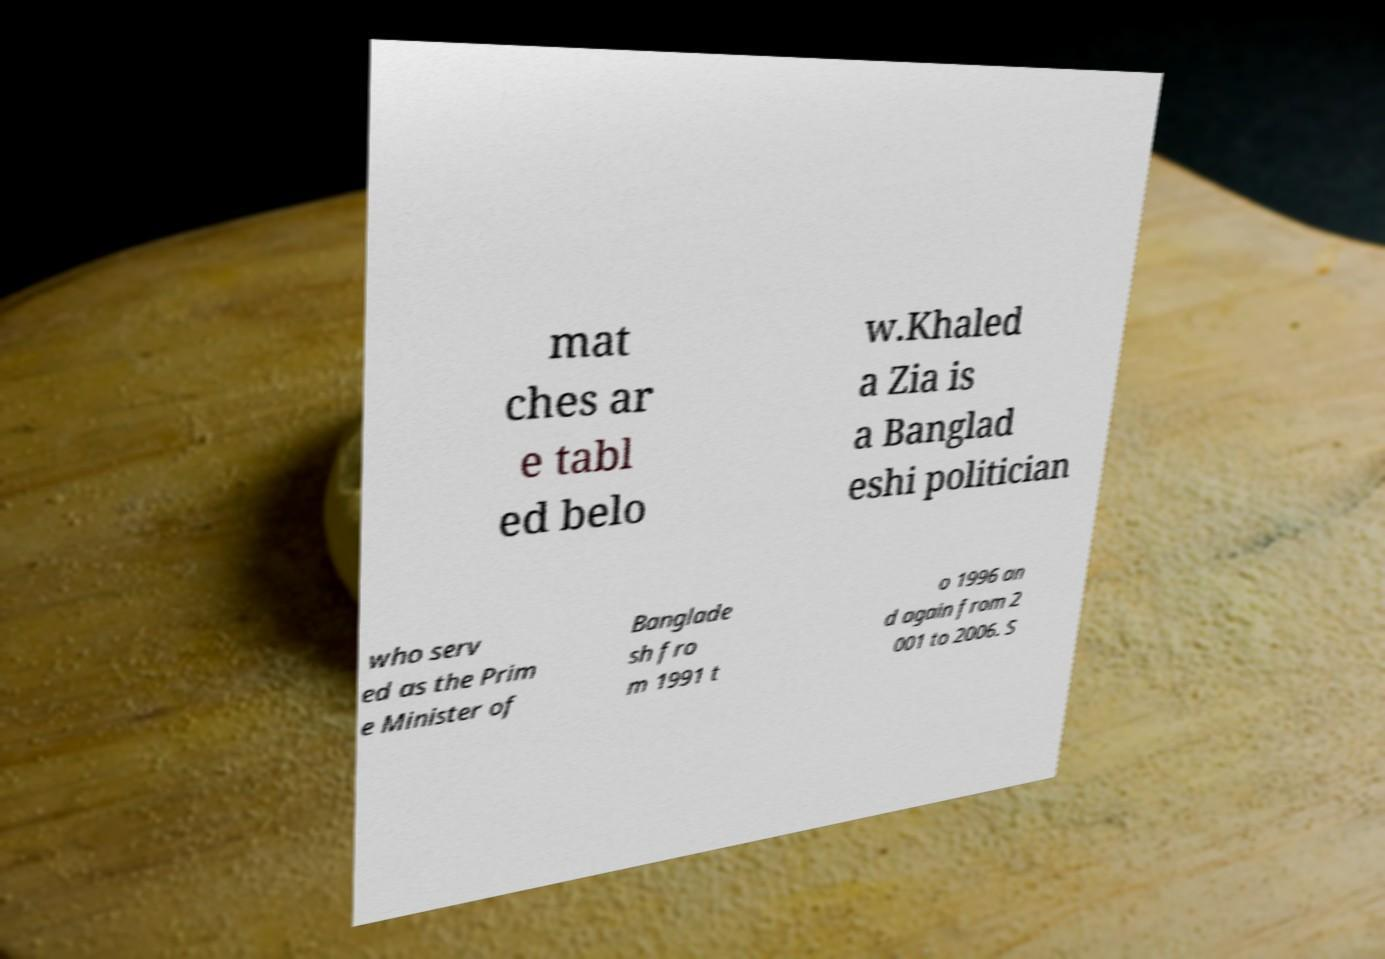Can you accurately transcribe the text from the provided image for me? mat ches ar e tabl ed belo w.Khaled a Zia is a Banglad eshi politician who serv ed as the Prim e Minister of Banglade sh fro m 1991 t o 1996 an d again from 2 001 to 2006. S 